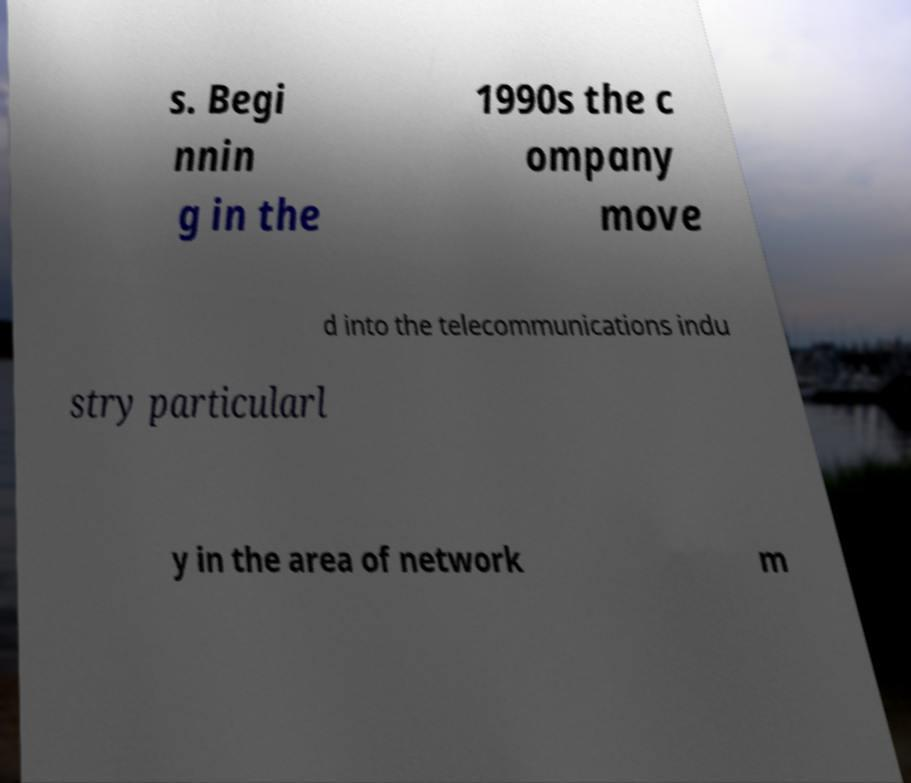Please read and relay the text visible in this image. What does it say? s. Begi nnin g in the 1990s the c ompany move d into the telecommunications indu stry particularl y in the area of network m 